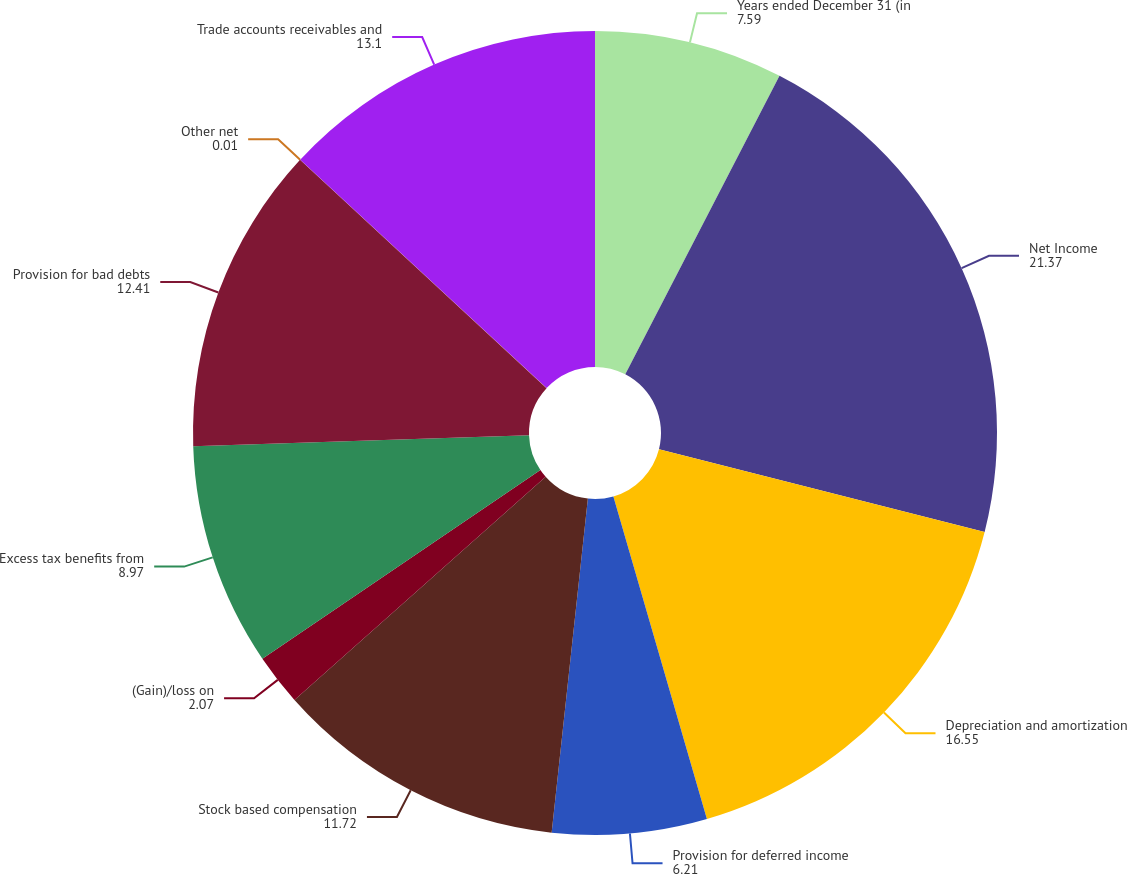Convert chart to OTSL. <chart><loc_0><loc_0><loc_500><loc_500><pie_chart><fcel>Years ended December 31 (in<fcel>Net Income<fcel>Depreciation and amortization<fcel>Provision for deferred income<fcel>Stock based compensation<fcel>(Gain)/loss on<fcel>Excess tax benefits from<fcel>Provision for bad debts<fcel>Other net<fcel>Trade accounts receivables and<nl><fcel>7.59%<fcel>21.37%<fcel>16.55%<fcel>6.21%<fcel>11.72%<fcel>2.07%<fcel>8.97%<fcel>12.41%<fcel>0.01%<fcel>13.1%<nl></chart> 